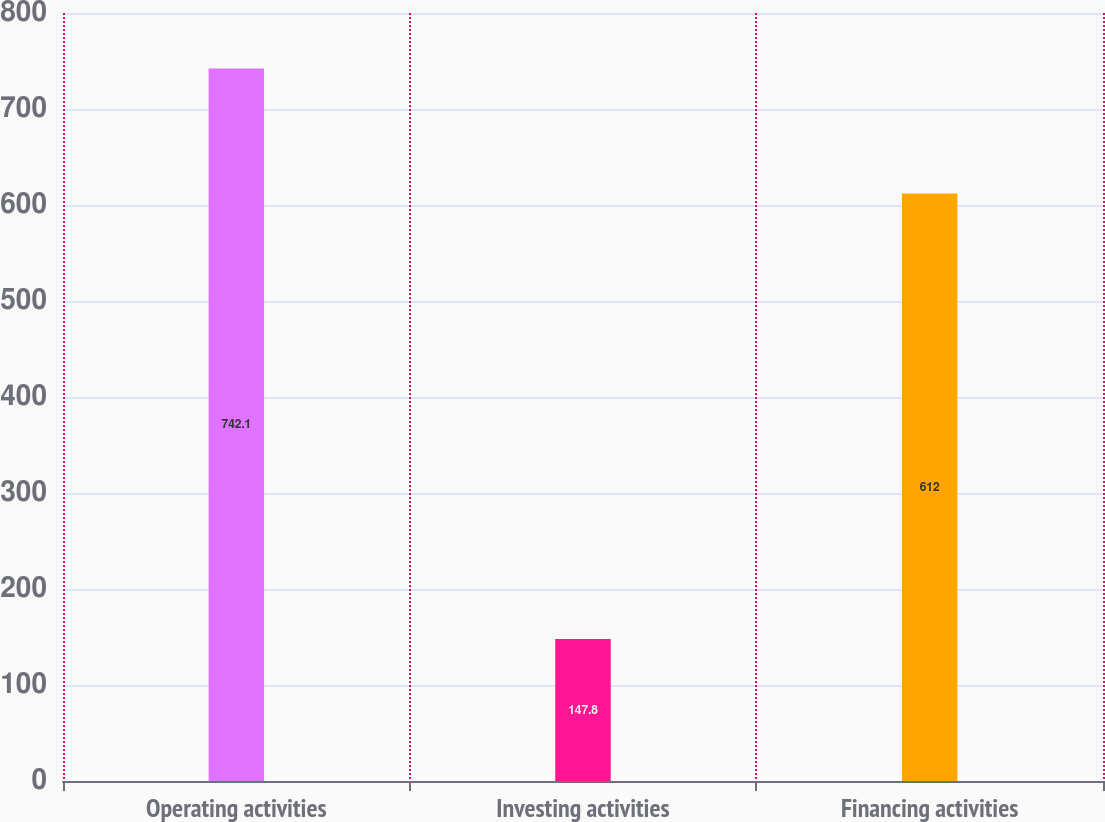Convert chart. <chart><loc_0><loc_0><loc_500><loc_500><bar_chart><fcel>Operating activities<fcel>Investing activities<fcel>Financing activities<nl><fcel>742.1<fcel>147.8<fcel>612<nl></chart> 